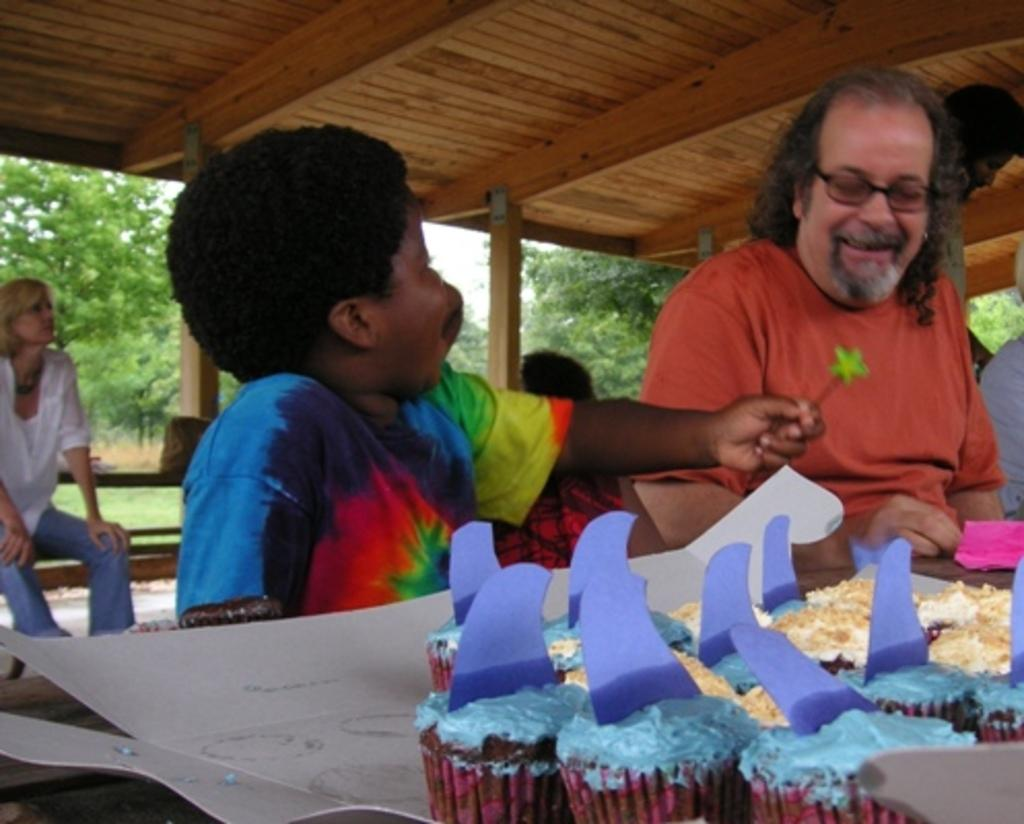What are the people in the image doing? The people in the image are sitting on a bench. Can you describe the boy in the image? The boy in the image is holding something in his hand. What type of food can be seen in the image? There are muffins visible in the image. What can be seen in the background of the image? There are trees in the background of the image. What does the boy's tongue look like in the image? There is no information about the boy's tongue in the image, as it is not visible or mentioned in the provided facts. Is the boy in the image a slave or an achiever? There is no information about the boy's status or achievements in the image, as it is not mentioned in the provided facts. 